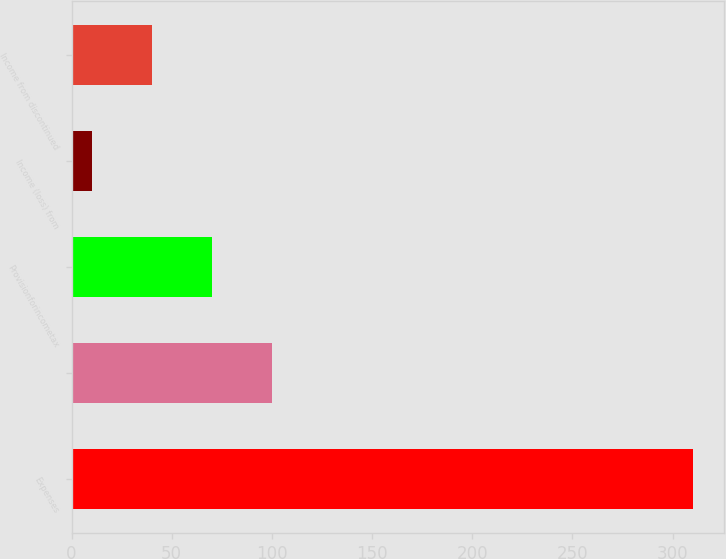Convert chart. <chart><loc_0><loc_0><loc_500><loc_500><bar_chart><fcel>Expenses<fcel>Unnamed: 1<fcel>Provisionforincometax<fcel>Income (loss) from<fcel>Income from discontinued<nl><fcel>310<fcel>100<fcel>70<fcel>10<fcel>40<nl></chart> 